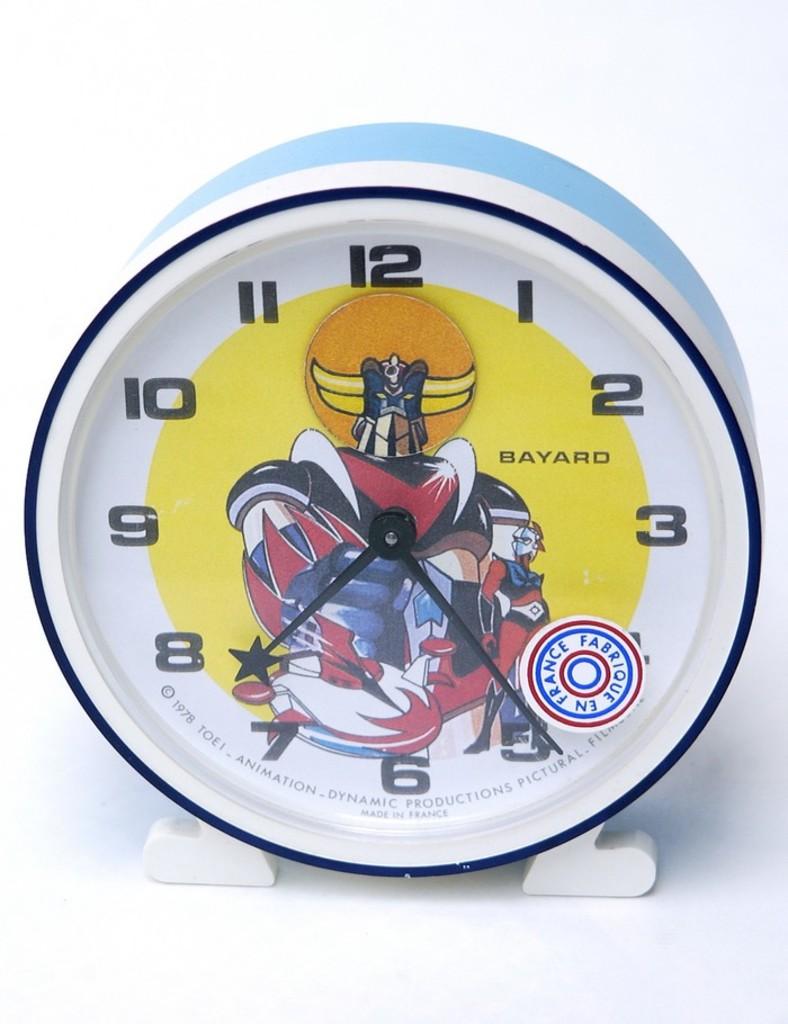Who makes the clock?
Your response must be concise. Bayard. What time is it>?
Give a very brief answer. 7:24. 